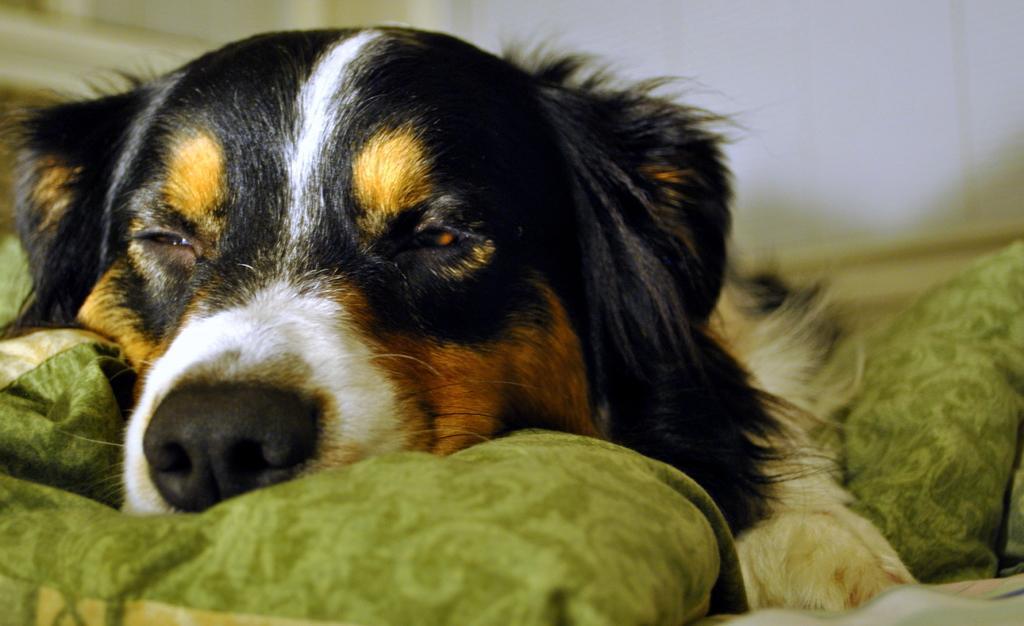Describe this image in one or two sentences. In the picture we can see a dog sleeping on the pillows which are green in color, the dog is black in color with some white and brown in color on it, in the background we can see the wall. 